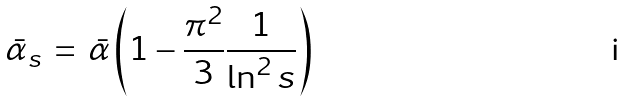<formula> <loc_0><loc_0><loc_500><loc_500>\bar { \alpha } _ { s } \, = \, { \bar { \alpha } } \left ( 1 - \frac { \pi ^ { 2 } } { 3 } \frac { 1 } { \ln ^ { 2 } s } \right ) \,</formula> 